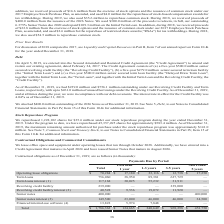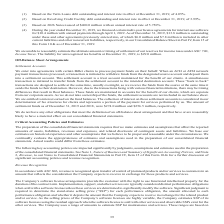According to Aci Worldwide's financial document, What were the term loans based on? the Term Loans debt outstanding and interest rate in effect at December 31, 2019, of 4.05%.. The document states: "(1) Based on the Term Loans debt outstanding and interest rate in effect at December 31, 2019, of 4.05%...." Also, What was the total term loans? According to the financial document, 756,060 (in thousands). The relevant text states: "Term loans 756,060 38,950 89,381 627,729 —..." Also, What was the total term loans interest? According to the financial document, 117,168 (in thousands). The relevant text states: "Term loans interest (1) 117,168 30,025 55,232 31,911 —..." Also, can you calculate: What percentage of the total consists of payments due less than 1 year? Based on the calculation: $124,665/$1,786,362, the result is 6.98 (percentage). This is based on the information: "Total $ 1,786,362 $ 124,665 $ 240,649 $ 969,298 $ 451,750 Total $ 1,786,362 $ 124,665 $ 240,649 $ 969,298 $ 451,750..." The key data points involved are: 1,786,362, 124,665. Also, can you calculate: What percentage of the total consists of payments due in 1-3 years? Based on the calculation: $240,649/$1,786,362, the result is 13.47 (percentage). This is based on the information: "Total $ 1,786,362 $ 124,665 $ 240,649 $ 969,298 $ 451,750 Total $ 1,786,362 $ 124,665 $ 240,649 $ 969,298 $ 451,750..." The key data points involved are: 1,786,362, 240,649. Also, can you calculate: What percentage of the total contractual obligations consists of term loans? Based on the calculation: 756,060/$1,786,362, the result is 42.32 (percentage). This is based on the information: "Total $ 1,786,362 $ 124,665 $ 240,649 $ 969,298 $ 451,750 Term loans 756,060 38,950 89,381 627,729 —..." The key data points involved are: 1,786,362, 756,060. 